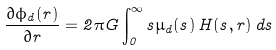<formula> <loc_0><loc_0><loc_500><loc_500>\frac { \partial \phi _ { d } ( r ) } { \partial r } = 2 \pi G \int _ { 0 } ^ { \infty } s \mu _ { d } ( s ) \, H ( s , r ) \, d s</formula> 